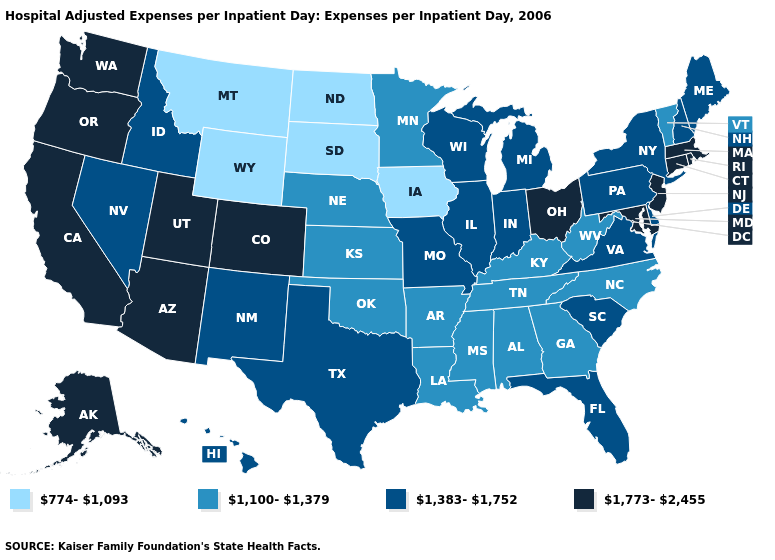Does Michigan have the same value as Colorado?
Be succinct. No. Does the map have missing data?
Short answer required. No. Name the states that have a value in the range 1,383-1,752?
Answer briefly. Delaware, Florida, Hawaii, Idaho, Illinois, Indiana, Maine, Michigan, Missouri, Nevada, New Hampshire, New Mexico, New York, Pennsylvania, South Carolina, Texas, Virginia, Wisconsin. What is the highest value in states that border Virginia?
Keep it brief. 1,773-2,455. Does Missouri have the lowest value in the MidWest?
Quick response, please. No. Name the states that have a value in the range 1,383-1,752?
Quick response, please. Delaware, Florida, Hawaii, Idaho, Illinois, Indiana, Maine, Michigan, Missouri, Nevada, New Hampshire, New Mexico, New York, Pennsylvania, South Carolina, Texas, Virginia, Wisconsin. Which states hav the highest value in the MidWest?
Give a very brief answer. Ohio. Does Montana have the lowest value in the USA?
Answer briefly. Yes. Name the states that have a value in the range 774-1,093?
Write a very short answer. Iowa, Montana, North Dakota, South Dakota, Wyoming. What is the highest value in states that border Vermont?
Short answer required. 1,773-2,455. Which states hav the highest value in the MidWest?
Be succinct. Ohio. What is the value of Arkansas?
Concise answer only. 1,100-1,379. Name the states that have a value in the range 1,773-2,455?
Short answer required. Alaska, Arizona, California, Colorado, Connecticut, Maryland, Massachusetts, New Jersey, Ohio, Oregon, Rhode Island, Utah, Washington. Name the states that have a value in the range 774-1,093?
Answer briefly. Iowa, Montana, North Dakota, South Dakota, Wyoming. Which states have the lowest value in the West?
Write a very short answer. Montana, Wyoming. 